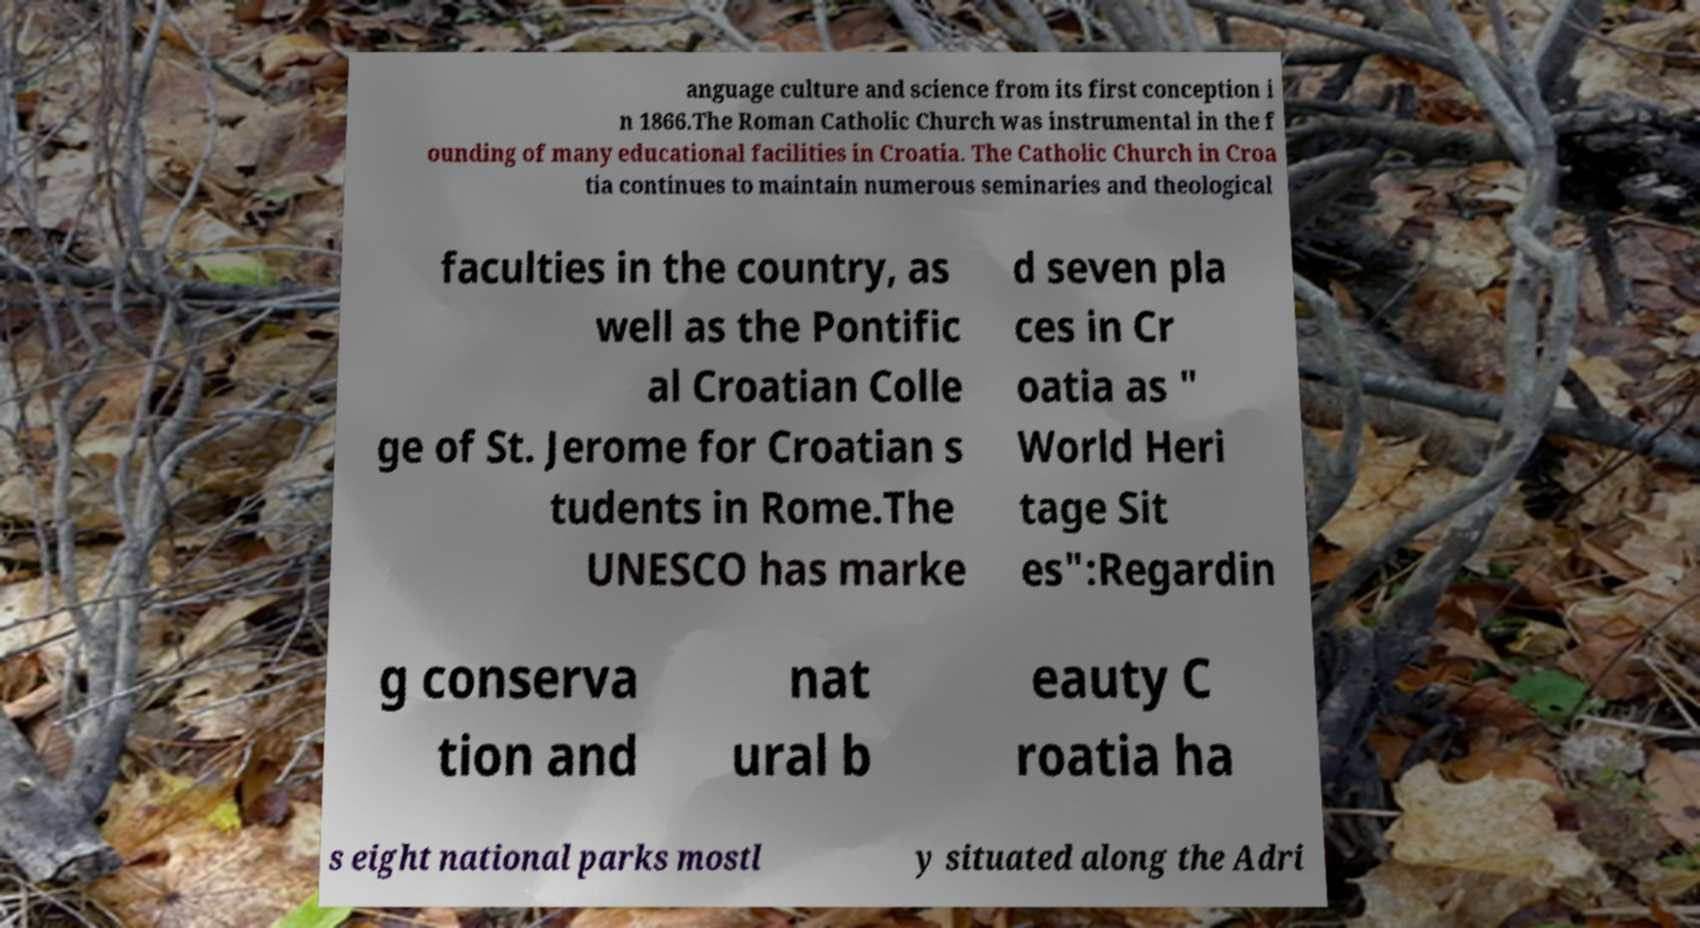Can you read and provide the text displayed in the image?This photo seems to have some interesting text. Can you extract and type it out for me? anguage culture and science from its first conception i n 1866.The Roman Catholic Church was instrumental in the f ounding of many educational facilities in Croatia. The Catholic Church in Croa tia continues to maintain numerous seminaries and theological faculties in the country, as well as the Pontific al Croatian Colle ge of St. Jerome for Croatian s tudents in Rome.The UNESCO has marke d seven pla ces in Cr oatia as " World Heri tage Sit es":Regardin g conserva tion and nat ural b eauty C roatia ha s eight national parks mostl y situated along the Adri 